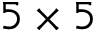Convert formula to latex. <formula><loc_0><loc_0><loc_500><loc_500>5 \times 5</formula> 